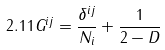<formula> <loc_0><loc_0><loc_500><loc_500>2 . 1 1 G ^ { i j } = \frac { \delta ^ { i j } } { N _ { i } } + \frac { 1 } { 2 - D }</formula> 